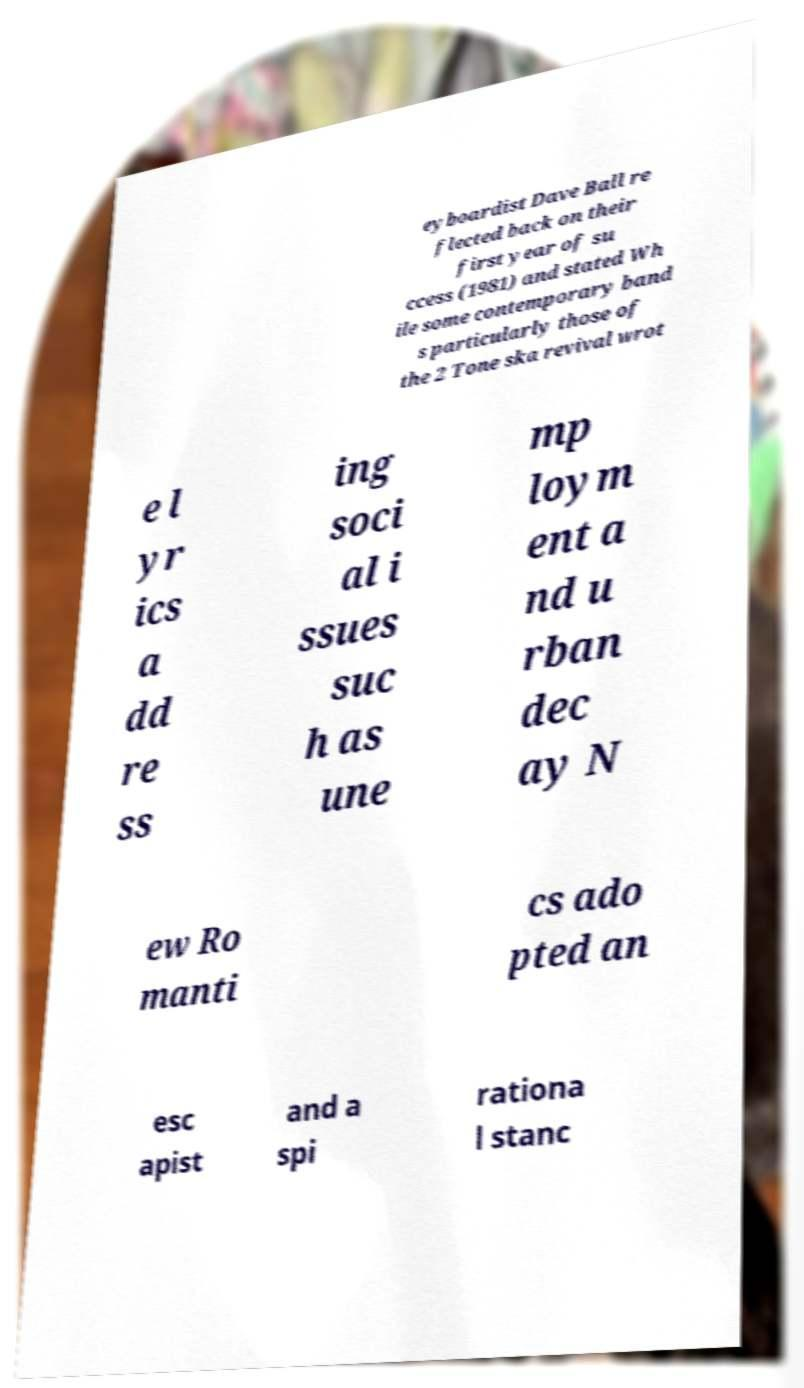There's text embedded in this image that I need extracted. Can you transcribe it verbatim? eyboardist Dave Ball re flected back on their first year of su ccess (1981) and stated Wh ile some contemporary band s particularly those of the 2 Tone ska revival wrot e l yr ics a dd re ss ing soci al i ssues suc h as une mp loym ent a nd u rban dec ay N ew Ro manti cs ado pted an esc apist and a spi rationa l stanc 